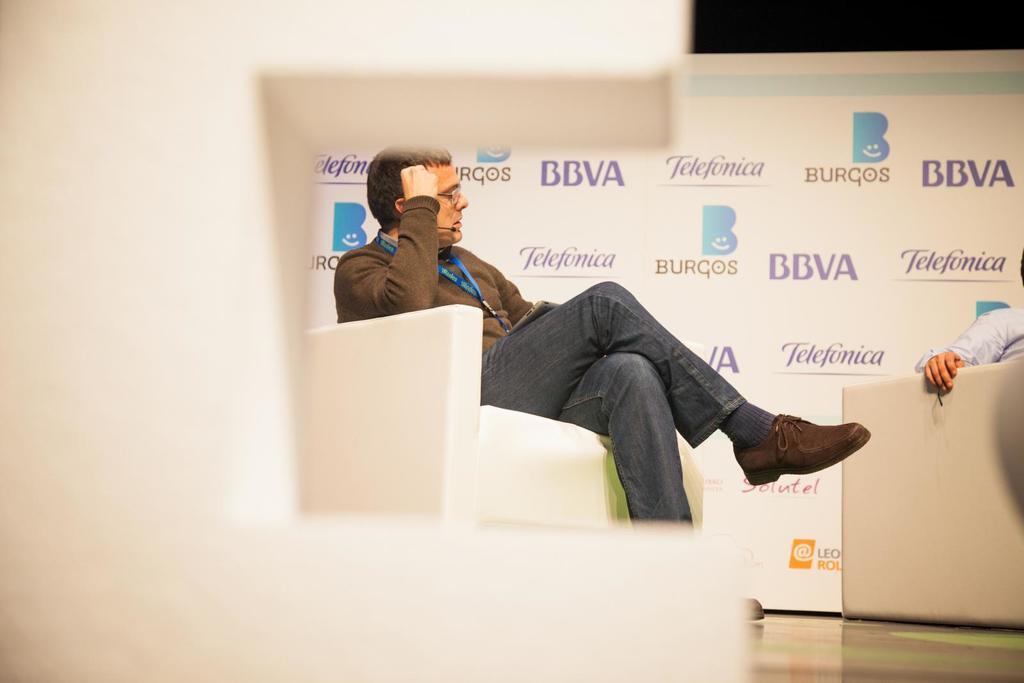In one or two sentences, can you explain what this image depicts? In the center of the image we can see a man is sitting on a couch and wearing id card, shoe, micro phone. On the right side of the image we can see a man is sitting on a couch. In the background of the image we can see the wall, board. At the bottom of the image we can see the floor. 